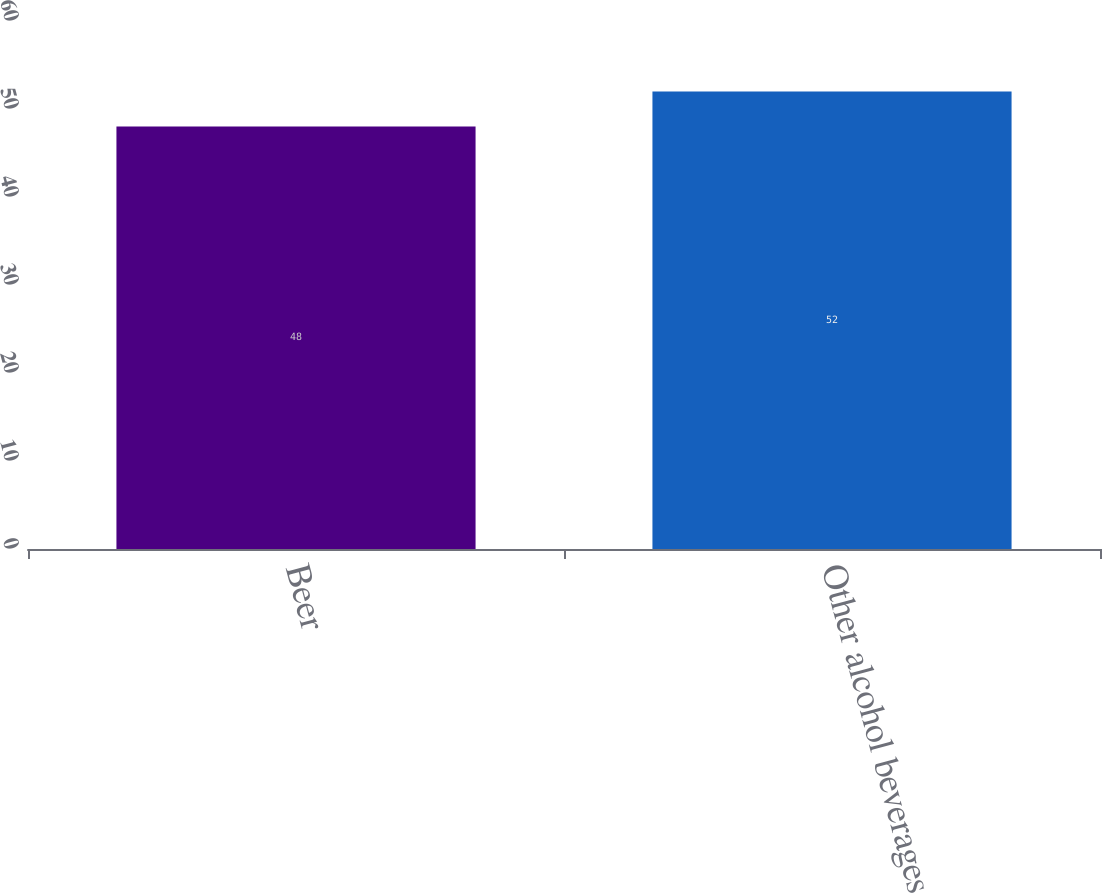Convert chart. <chart><loc_0><loc_0><loc_500><loc_500><bar_chart><fcel>Beer<fcel>Other alcohol beverages<nl><fcel>48<fcel>52<nl></chart> 